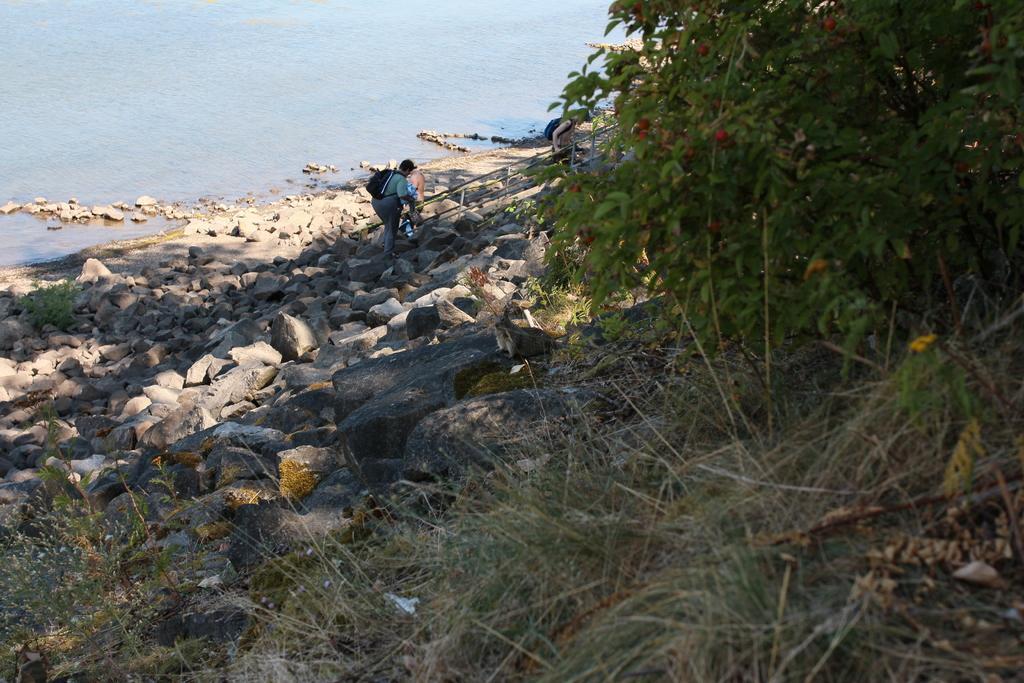How would you summarize this image in a sentence or two? In the background we can see water and stones. There is a person standing, wearing a backpack. On the right side of the picture we can see a plant and the grass. 